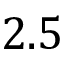Convert formula to latex. <formula><loc_0><loc_0><loc_500><loc_500>2 . 5</formula> 